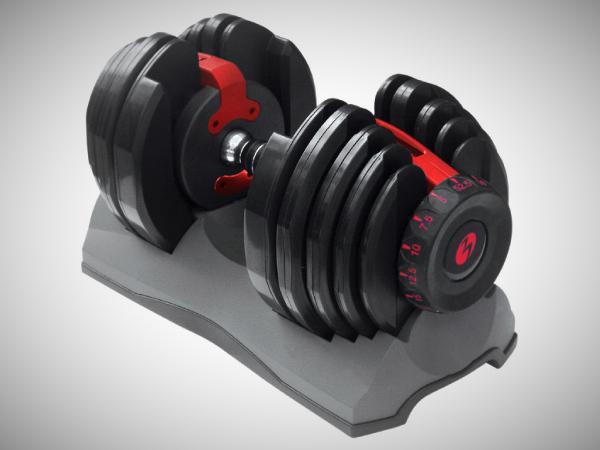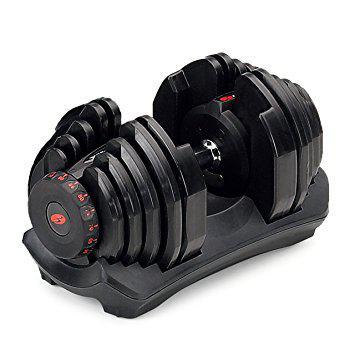The first image is the image on the left, the second image is the image on the right. Analyze the images presented: Is the assertion "There is exactly one hand visible." valid? Answer yes or no. No. The first image is the image on the left, the second image is the image on the right. Considering the images on both sides, is "There are three dumbbells." valid? Answer yes or no. No. 